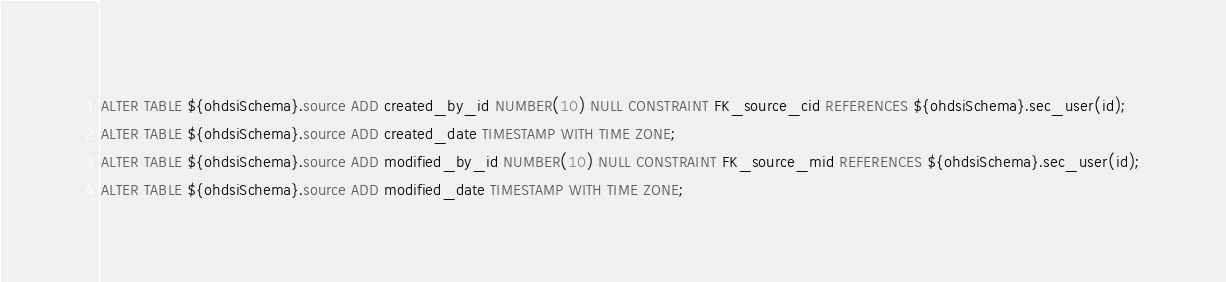Convert code to text. <code><loc_0><loc_0><loc_500><loc_500><_SQL_>ALTER TABLE ${ohdsiSchema}.source ADD created_by_id NUMBER(10) NULL CONSTRAINT FK_source_cid REFERENCES ${ohdsiSchema}.sec_user(id);
ALTER TABLE ${ohdsiSchema}.source ADD created_date TIMESTAMP WITH TIME ZONE;
ALTER TABLE ${ohdsiSchema}.source ADD modified_by_id NUMBER(10) NULL CONSTRAINT FK_source_mid REFERENCES ${ohdsiSchema}.sec_user(id);
ALTER TABLE ${ohdsiSchema}.source ADD modified_date TIMESTAMP WITH TIME ZONE;</code> 